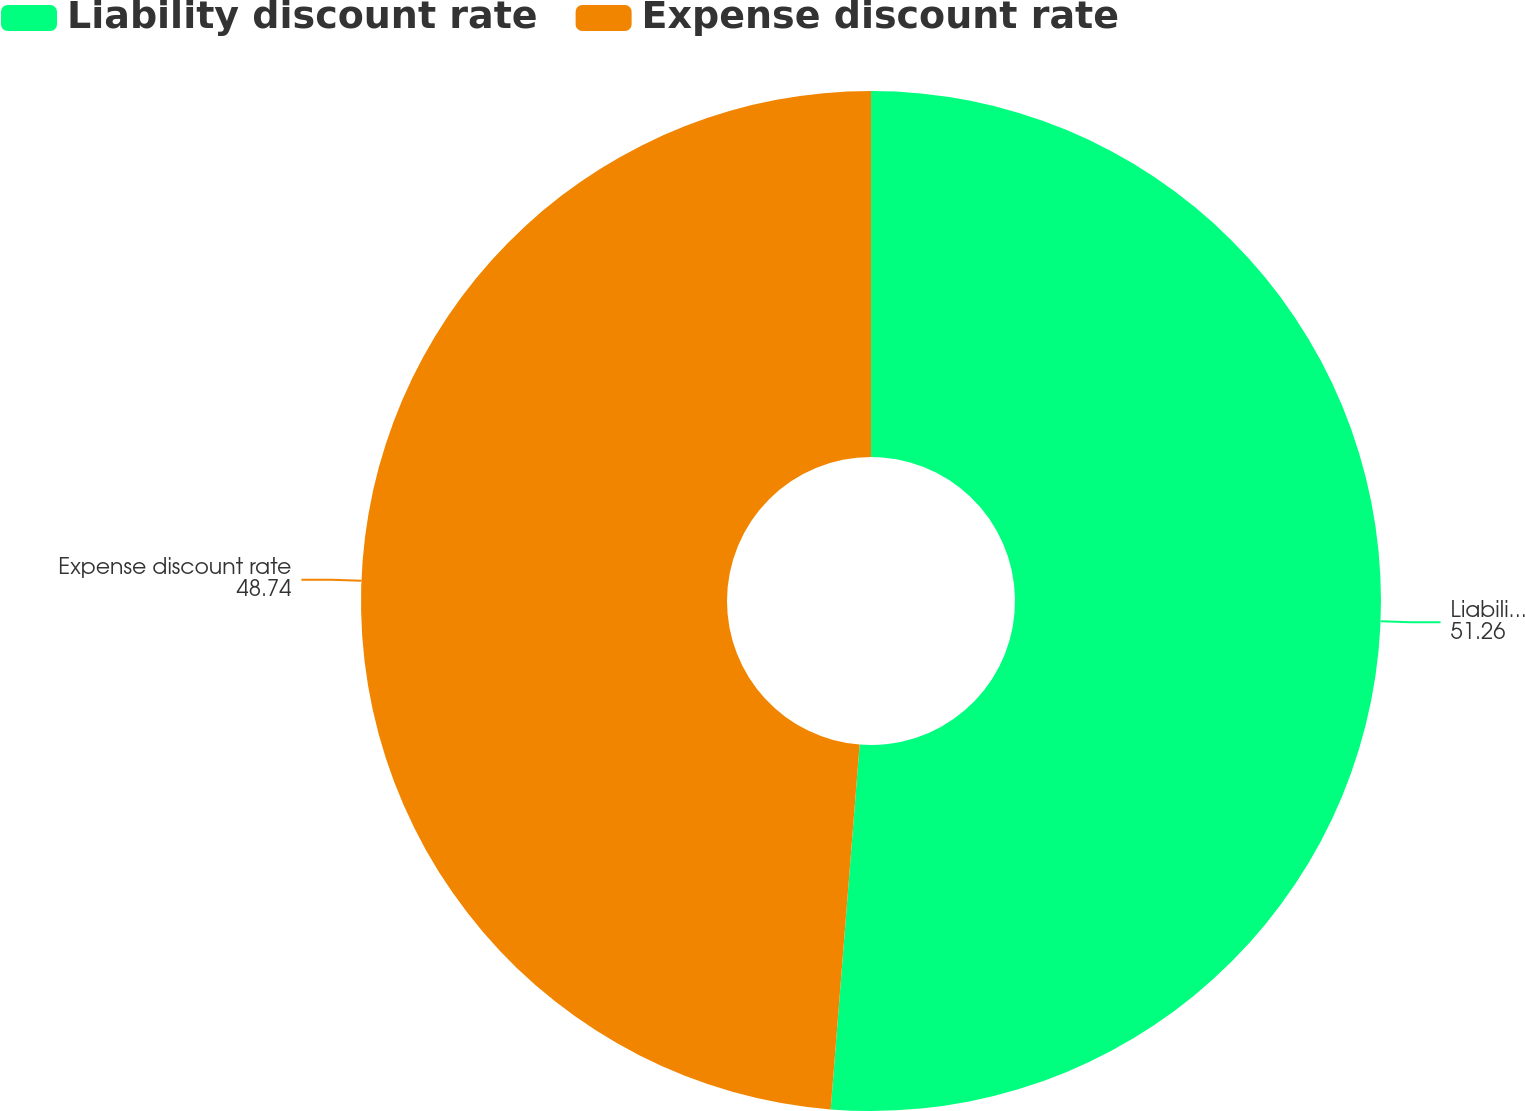Convert chart to OTSL. <chart><loc_0><loc_0><loc_500><loc_500><pie_chart><fcel>Liability discount rate<fcel>Expense discount rate<nl><fcel>51.26%<fcel>48.74%<nl></chart> 